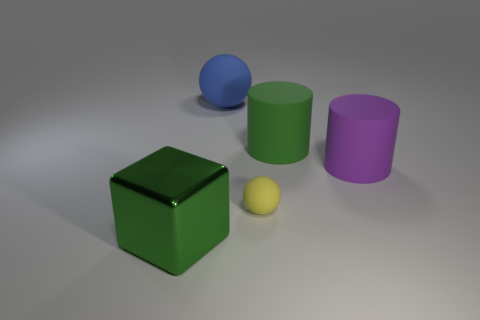Do the large shiny thing and the rubber thing to the left of the tiny thing have the same color?
Your answer should be very brief. No. There is a large cube on the left side of the sphere on the right side of the large matte thing to the left of the small yellow rubber sphere; what color is it?
Keep it short and to the point. Green. There is another small object that is the same shape as the blue object; what color is it?
Your answer should be compact. Yellow. Are there the same number of tiny yellow matte things that are on the left side of the big blue thing and large matte balls?
Your response must be concise. No. How many cubes are either tiny objects or green objects?
Your answer should be very brief. 1. What is the color of the sphere that is the same material as the small object?
Your answer should be very brief. Blue. Is the material of the purple object the same as the big green thing in front of the tiny ball?
Give a very brief answer. No. What number of things are purple cubes or small yellow matte things?
Provide a short and direct response. 1. There is another large object that is the same color as the big metallic object; what material is it?
Keep it short and to the point. Rubber. Is there a big purple shiny object of the same shape as the tiny yellow object?
Give a very brief answer. No. 